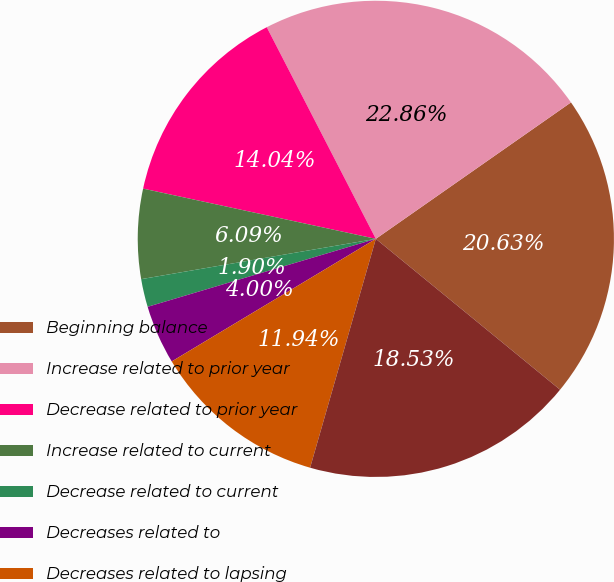Convert chart. <chart><loc_0><loc_0><loc_500><loc_500><pie_chart><fcel>Beginning balance<fcel>Increase related to prior year<fcel>Decrease related to prior year<fcel>Increase related to current<fcel>Decrease related to current<fcel>Decreases related to<fcel>Decreases related to lapsing<fcel>Ending balance<nl><fcel>20.63%<fcel>22.86%<fcel>14.04%<fcel>6.09%<fcel>1.9%<fcel>4.0%<fcel>11.94%<fcel>18.53%<nl></chart> 